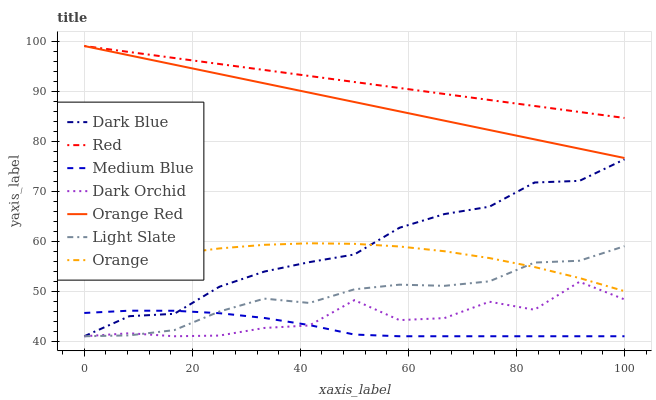Does Dark Orchid have the minimum area under the curve?
Answer yes or no. No. Does Dark Orchid have the maximum area under the curve?
Answer yes or no. No. Is Medium Blue the smoothest?
Answer yes or no. No. Is Medium Blue the roughest?
Answer yes or no. No. Does Orange have the lowest value?
Answer yes or no. No. Does Dark Orchid have the highest value?
Answer yes or no. No. Is Medium Blue less than Red?
Answer yes or no. Yes. Is Orange Red greater than Dark Orchid?
Answer yes or no. Yes. Does Medium Blue intersect Red?
Answer yes or no. No. 